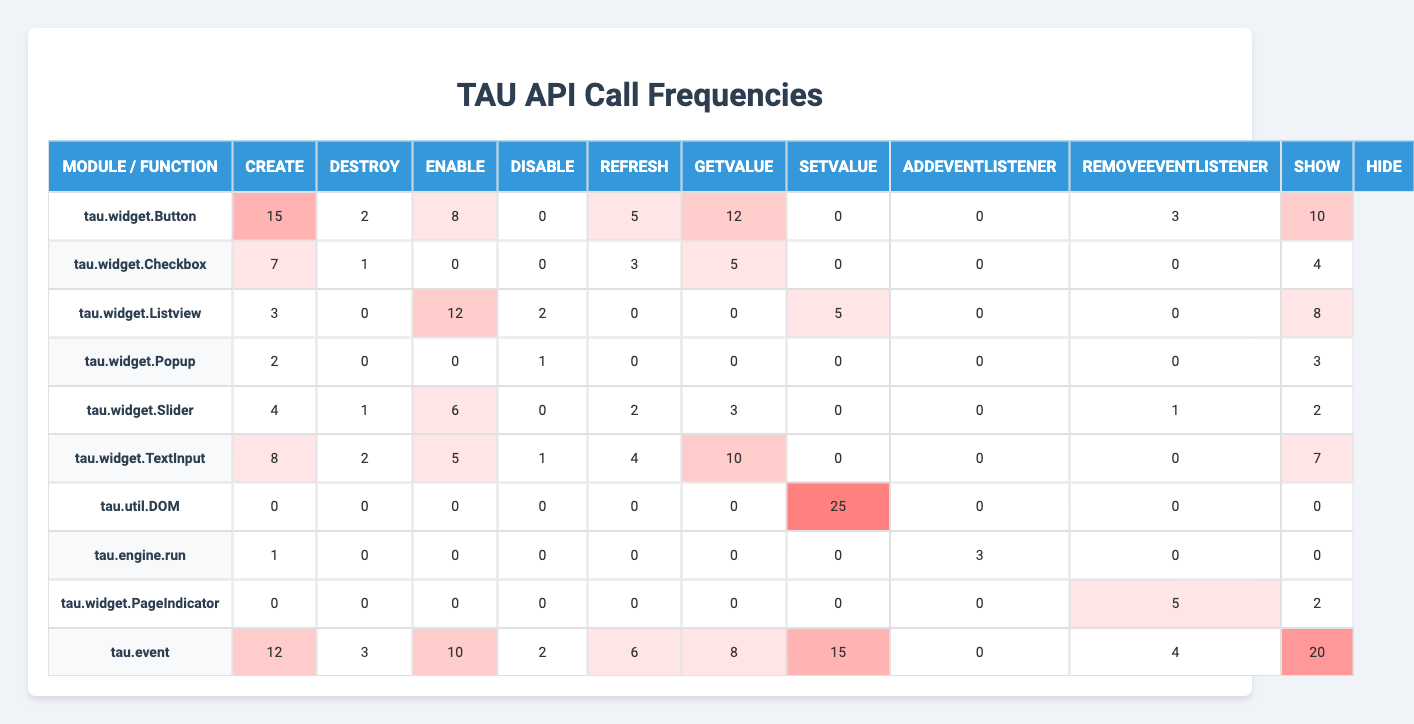What's the highest frequency of the 'create' function call among the modules? By looking at the 'create' column in the table, the highest value is 15 for the module 'tau.widget.Button'.
Answer: 15 Which module has the least number of 'destroy' function calls? The 'destroy' column shows that the module 'tau.widget.Listview' has 0 calls, which is the least.
Answer: tau.widget.Listview What is the average number of 'enable' function calls across all modules? To find the average for 'enable', sum the values (2+1+0+0+1+2+0+0+0+1 = 7) and divide by the number of modules (10). So, the average is 7/10 = 0.7.
Answer: 0.7 Is there a module that makes no 'refresh' function calls? By inspecting the 'refresh' column, both 'tau.widget.Checkbox' and 'tau.widget.Popup' show a value of 0 for 'refresh'.
Answer: Yes What is the total number of function calls made by 'tau.util.DOM'? Summing the row corresponding to 'tau.util.DOM' gives us (0+0+0+0+0+0+25+0+0+0 = 25).
Answer: 25 Which module has the highest total function calls across all types? Calculating the total for each module: 'tau.widget.Button' (60), 'tau.widget.Checkbox' (20), 'tau.widget.Listview' (39), 'tau.widget.Popup' (4), 'tau.widget.Slider' (18), 'tau.widget.TextInput' (35), 'tau.util.DOM' (25), 'tau.engine.run' (3), 'tau.widget.PageIndicator' (7), 'tau.event' (48). Therefore, 'tau.widget.Button' has the highest total calls.
Answer: tau.widget.Button What is the total count of 'hide' function calls across all modules? The 'hide' column contains values [10, 4, 8, 3, 2, 7, 0, 0, 2, 20]. Summing these gives 10 + 4 + 8 + 3 + 2 + 7 + 0 + 0 + 2 + 20 = 56.
Answer: 56 Does 'tau.widget.Slider' have more 'setValue' calls than 'tau.widget.Checkbox'? Looking at the 'setValue' values, 'tau.widget.Slider' has 4 calls while 'tau.widget.Checkbox' has 0. Therefore, 'tau.widget.Slider' has more calls.
Answer: Yes Which module made the maximum number of 'addEventListener' calls? Reviewing the 'addEventListener' column, 'tau.util.DOM' has 0 calls while 'tau.widget.Button' has 0, 'tau.widget.Listview' has 5, 'tau.widget.Slider' has 0, and 'tau.event' has 0, Thus, 'tau.widget.Listview' has the maximum at 5.
Answer: tau.widget.Listview What is the difference in 'getValue' calls between 'tau.widget.TextInput' and 'tau.widget.Popup'? The 'getValue' values are 0 for 'tau.widget.Popup' and 10 for 'tau.widget.TextInput'. Thus, the difference is 10 - 0 = 10.
Answer: 10 How many modules have a 'disable' function call greater than 1? The 'disable' counts are [2, 0, 2, 1, 0, 1, 0, 0, 0, 1]. The only modules with calls greater than 1 are 'tau.widget.Button', 'tau.widget.Listview', and 'tau.widget.Slider', totalling 3 modules.
Answer: 3 